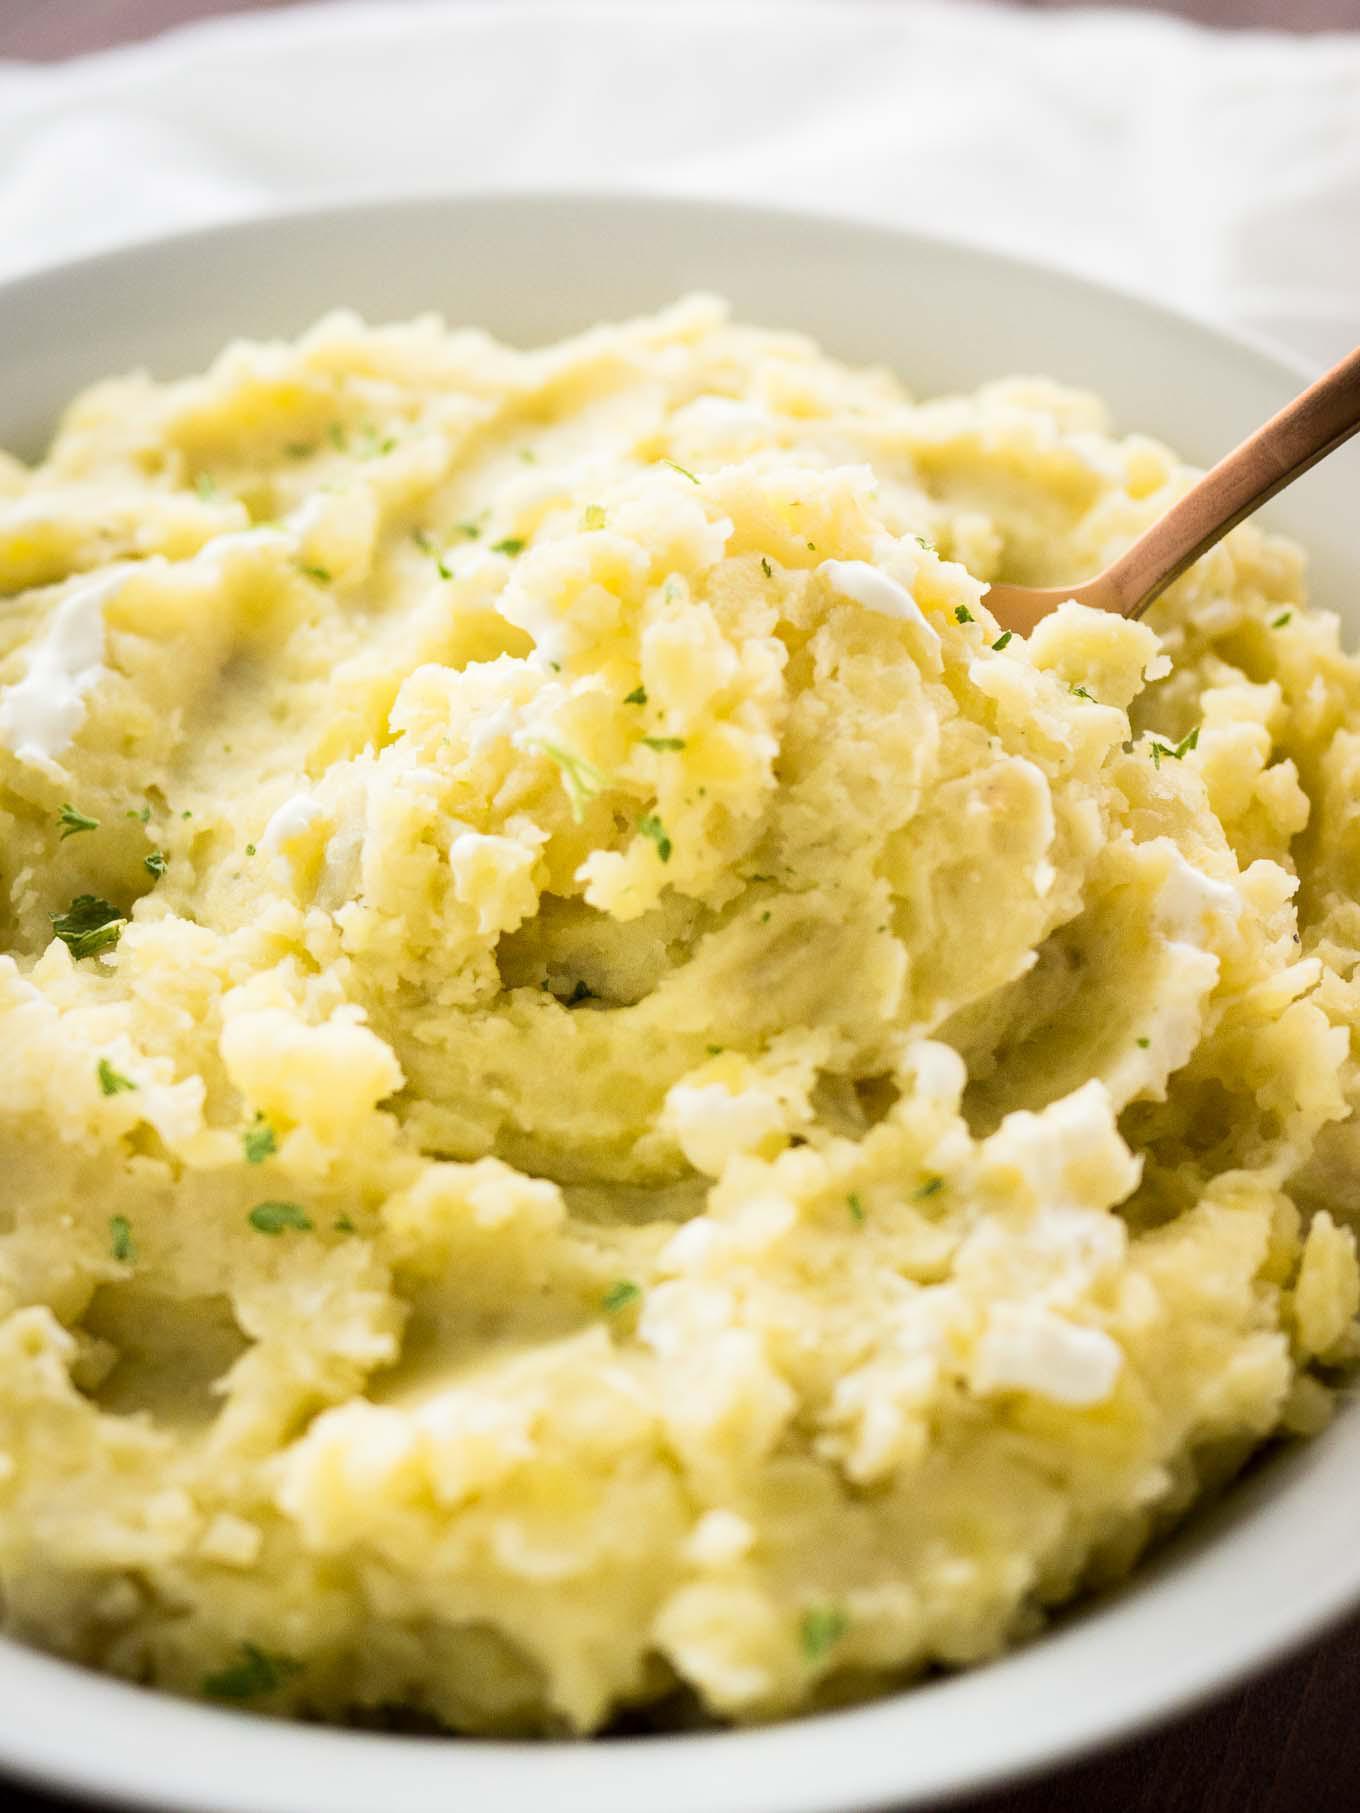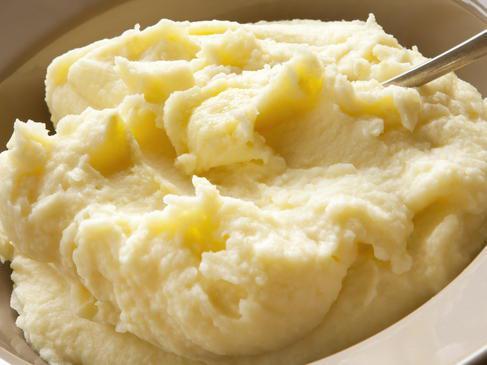The first image is the image on the left, the second image is the image on the right. Assess this claim about the two images: "There is a bowl of mashed potatoes with a spoon in it". Correct or not? Answer yes or no. Yes. The first image is the image on the left, the second image is the image on the right. For the images shown, is this caption "No bowl of potatoes has a utensil handle sticking out of it." true? Answer yes or no. No. 